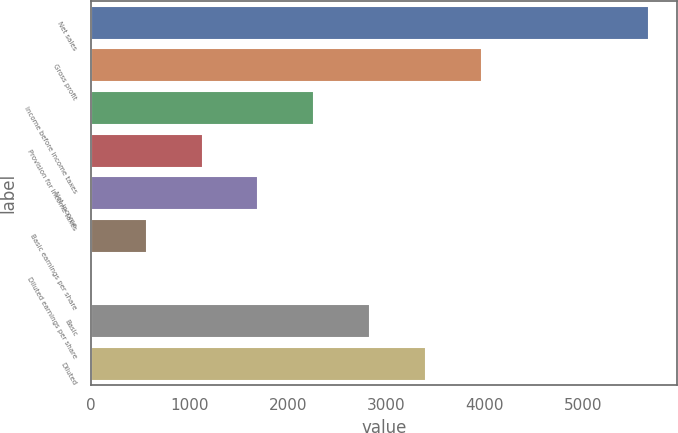Convert chart. <chart><loc_0><loc_0><loc_500><loc_500><bar_chart><fcel>Net sales<fcel>Gross profit<fcel>Income before income taxes<fcel>Provision for income taxes<fcel>Net income<fcel>Basic earnings per share<fcel>Diluted earnings per share<fcel>Basic<fcel>Diluted<nl><fcel>5673<fcel>3971.23<fcel>2269.48<fcel>1134.98<fcel>1702.23<fcel>567.73<fcel>0.48<fcel>2836.73<fcel>3403.98<nl></chart> 